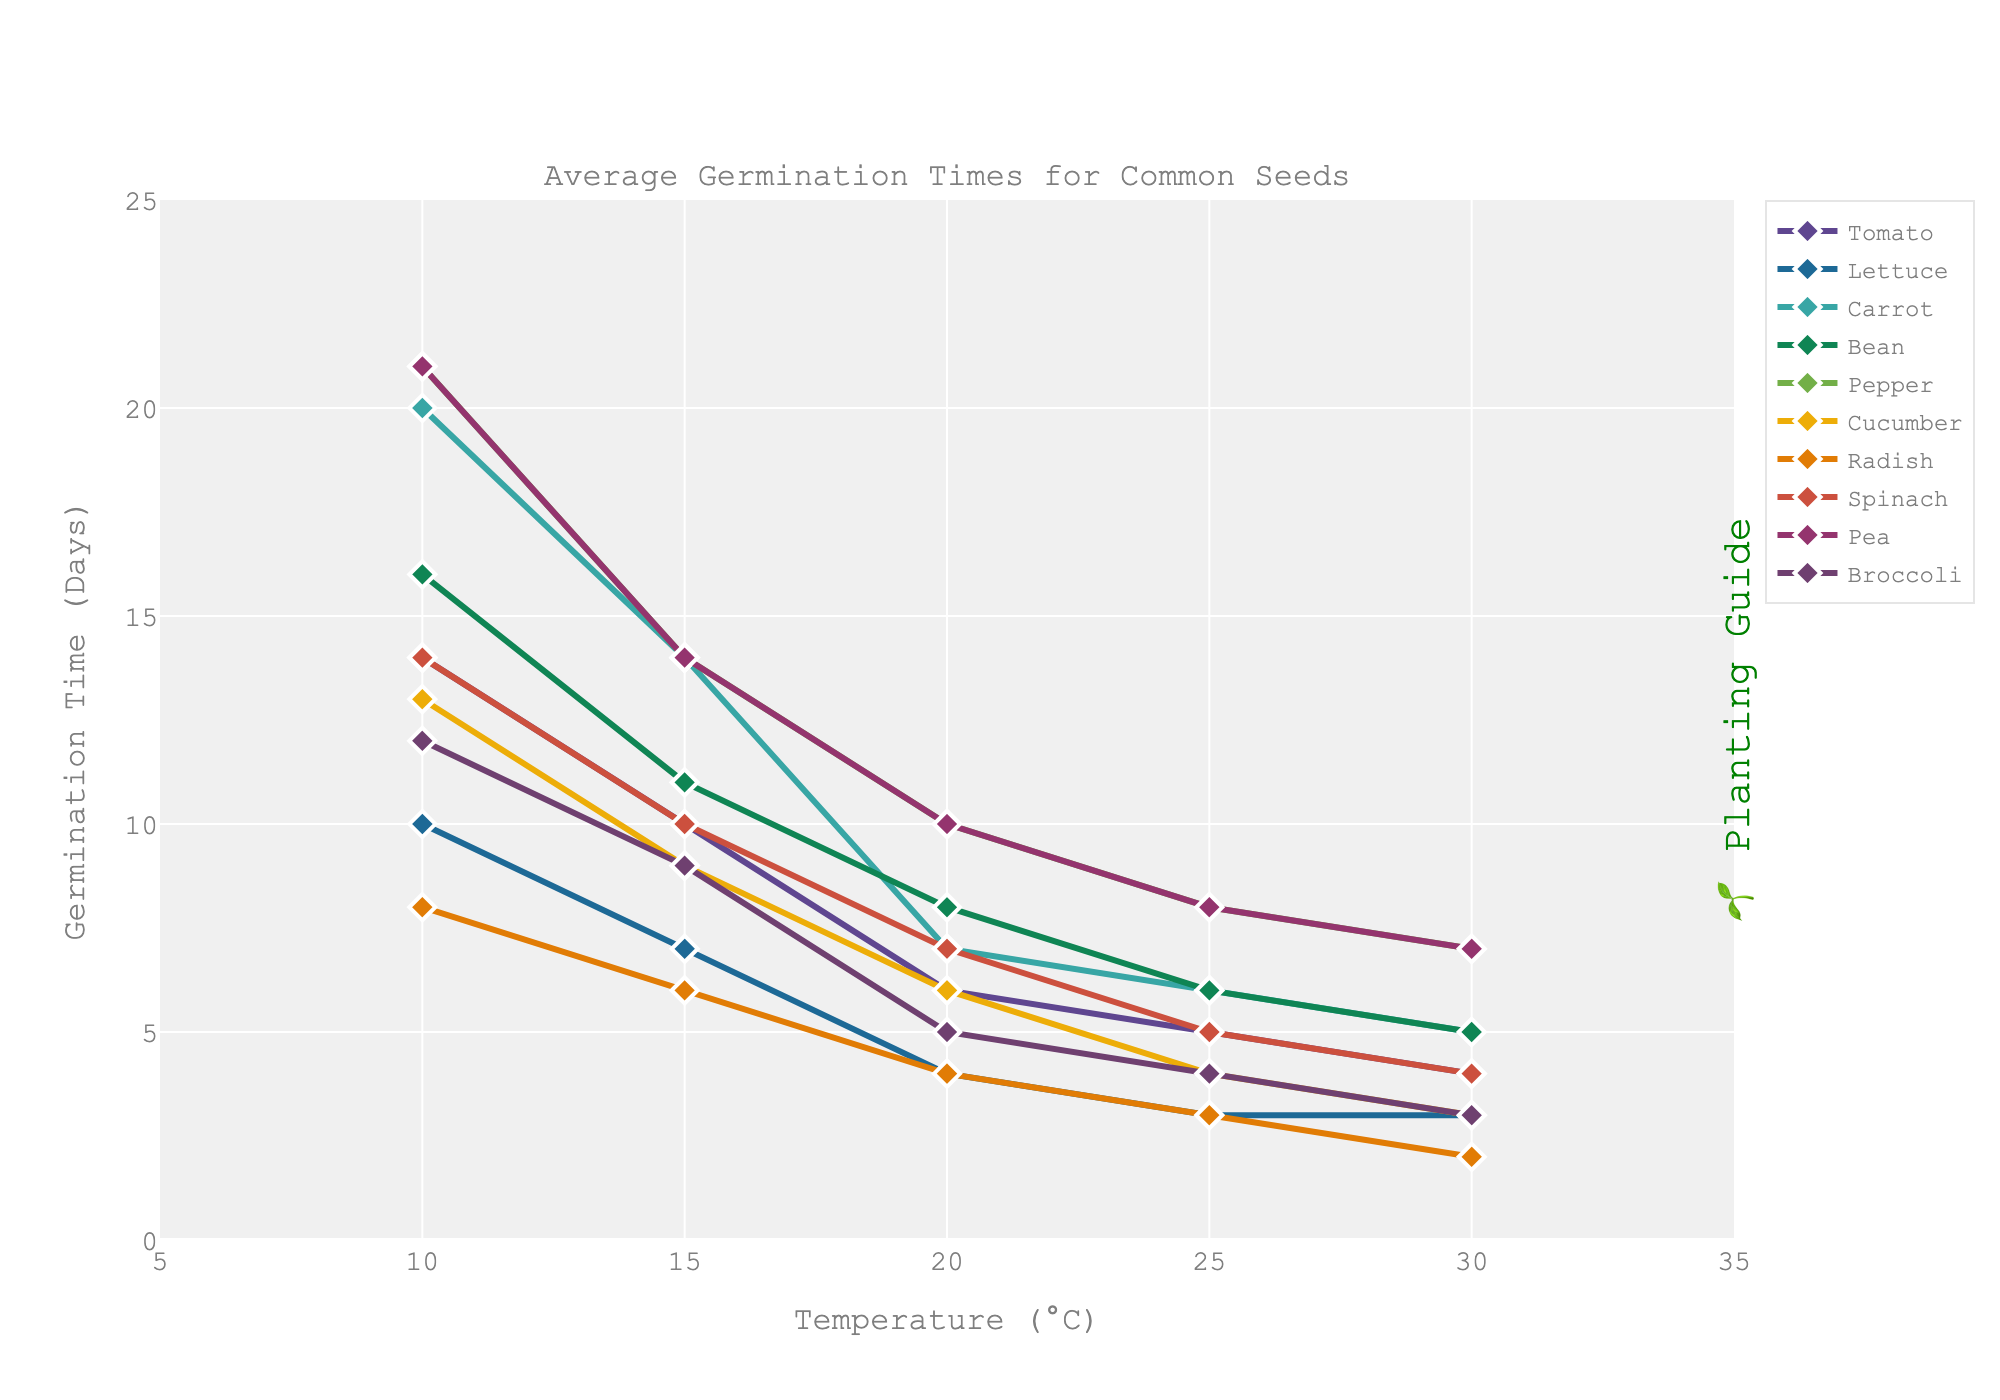Which seed type has the shortest germination time at 10°C? By looking at the y-axis values at 10°C, Radish has the shortest germination time at 8 days.
Answer: Radish Which two seed types have the same germination time at 30°C? Examining the y-axis values at 30°C, Lettuce and Cucumber both germinate in 3 days.
Answer: Lettuce and Cucumber What is the average germination time for Pepper seeds across all temperature conditions? Sum the germination times for Pepper at each temperature: 21 + 14 + 10 + 8 + 7 = 60. Divide by the number of temperature conditions: 60 / 5 = 12.
Answer: 12 At what temperature do Cucumber seeds germinate faster than Spinach seeds by 3 days? At 25°C, Cucumber germinates in 4 days, and Spinach in 7 days, which is a difference of 3 days.
Answer: 25°C How does the germination time of Tomatoes at 20°C compare to Peas at the same temperature? At 20°C, Tomato seeds germinate in 6 days while Peas take 10 days, indicating that Tomatoes germinate faster.
Answer: Tomatoes germinate faster Which seed type has the largest decrease in germination time from 10°C to 30°C? Calculate the decrease: for Tomato it's from 14 to 4 (10), Lettuce 10 to 3 (7), Carrot 20 to 5 (15), Bean 16 to 5 (11), Pepper 21 to 7 (14), Cucumber 13 to 3 (10), Radish 8 to 2 (6), Spinach 14 to 4 (10), Pea 21 to 7 (14), Broccoli 12 to 3 (9). Carrot has the largest decrease of 15 days.
Answer: Carrot What is the germination time difference between Beans and Broccoli at 25°C? From the y-axis at 25°C, Beans germinate in 6 days and Broccoli in 4 days, so the difference is 2 days.
Answer: 2 days How does the germination time of Radish seeds at 15°C compare to Lettuce seeds at the same temperature? Radish germinates in 6 days while Lettuce germinates in 7 days at 15°C. Radish germinates 1 day faster than Lettuce.
Answer: Radish germinates faster By how many days does the germination time of Spinach decrease when the temperature rises from 10°C to 25°C? Spinach germinates in 14 days at 10°C and 5 days at 25°C. The difference is 14 - 5 = 9 days.
Answer: 9 days 